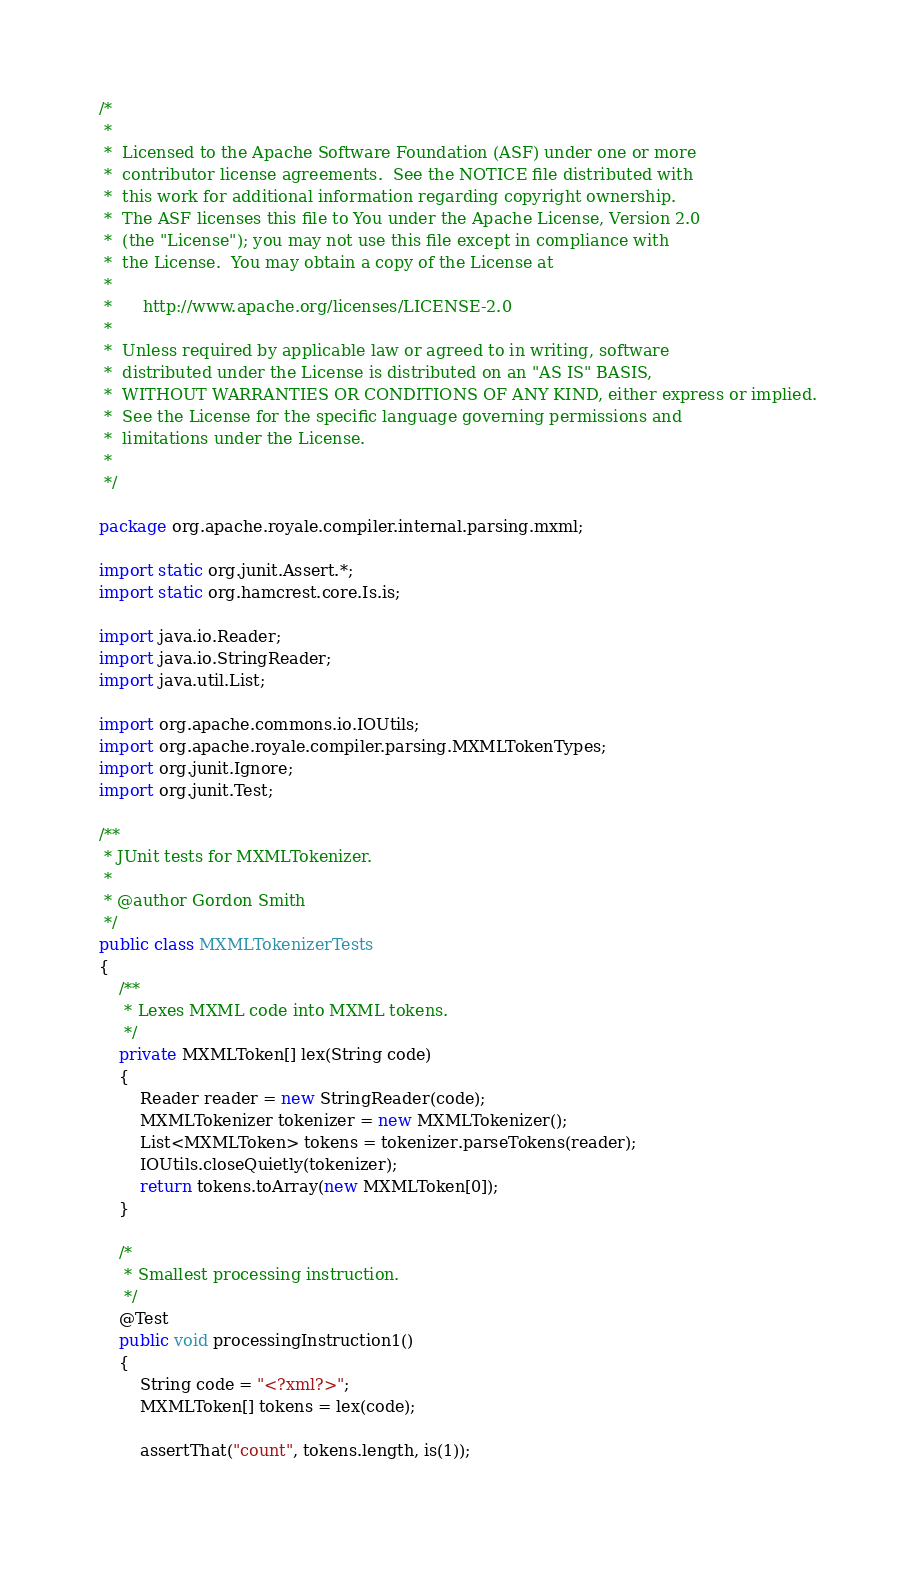<code> <loc_0><loc_0><loc_500><loc_500><_Java_>/*
 *
 *  Licensed to the Apache Software Foundation (ASF) under one or more
 *  contributor license agreements.  See the NOTICE file distributed with
 *  this work for additional information regarding copyright ownership.
 *  The ASF licenses this file to You under the Apache License, Version 2.0
 *  (the "License"); you may not use this file except in compliance with
 *  the License.  You may obtain a copy of the License at
 *
 *      http://www.apache.org/licenses/LICENSE-2.0
 *
 *  Unless required by applicable law or agreed to in writing, software
 *  distributed under the License is distributed on an "AS IS" BASIS,
 *  WITHOUT WARRANTIES OR CONDITIONS OF ANY KIND, either express or implied.
 *  See the License for the specific language governing permissions and
 *  limitations under the License.
 *
 */

package org.apache.royale.compiler.internal.parsing.mxml;

import static org.junit.Assert.*;
import static org.hamcrest.core.Is.is;

import java.io.Reader;
import java.io.StringReader;
import java.util.List;

import org.apache.commons.io.IOUtils;
import org.apache.royale.compiler.parsing.MXMLTokenTypes;
import org.junit.Ignore;
import org.junit.Test;

/**
 * JUnit tests for MXMLTokenizer.
 * 
 * @author Gordon Smith
 */
public class MXMLTokenizerTests
{
	/**
	 * Lexes MXML code into MXML tokens.
	 */
	private MXMLToken[] lex(String code)
	{
		Reader reader = new StringReader(code);
		MXMLTokenizer tokenizer = new MXMLTokenizer();
		List<MXMLToken> tokens = tokenizer.parseTokens(reader);
		IOUtils.closeQuietly(tokenizer);
		return tokens.toArray(new MXMLToken[0]);
	}
	
	/*
	 * Smallest processing instruction.
	 */
	@Test
	public void processingInstruction1()
	{
		String code = "<?xml?>";
		MXMLToken[] tokens = lex(code);
		
		assertThat("count", tokens.length, is(1));
		</code> 